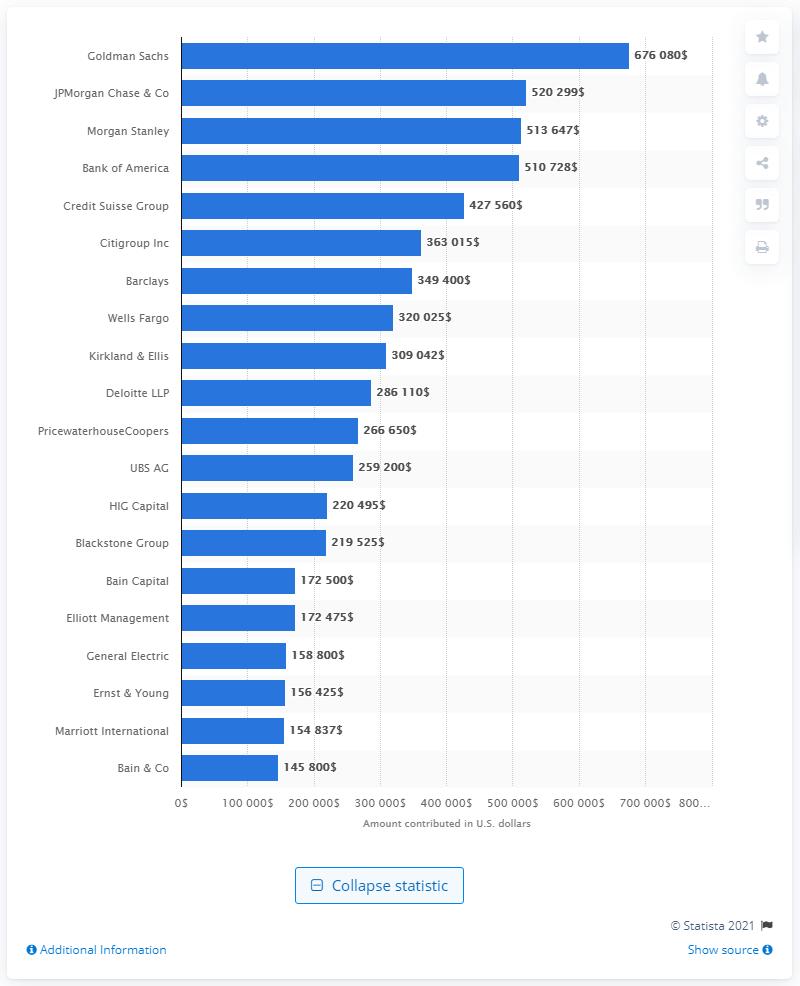Identify some key points in this picture. The most significant donor to the Romney campaign was Goldman Sachs. JPMorgan Chase & Co. was the second largest donor to the Romney campaign. 